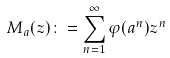<formula> <loc_0><loc_0><loc_500><loc_500>M _ { a } ( z ) \colon = \sum _ { n = 1 } ^ { \infty } \varphi ( a ^ { n } ) z ^ { n }</formula> 